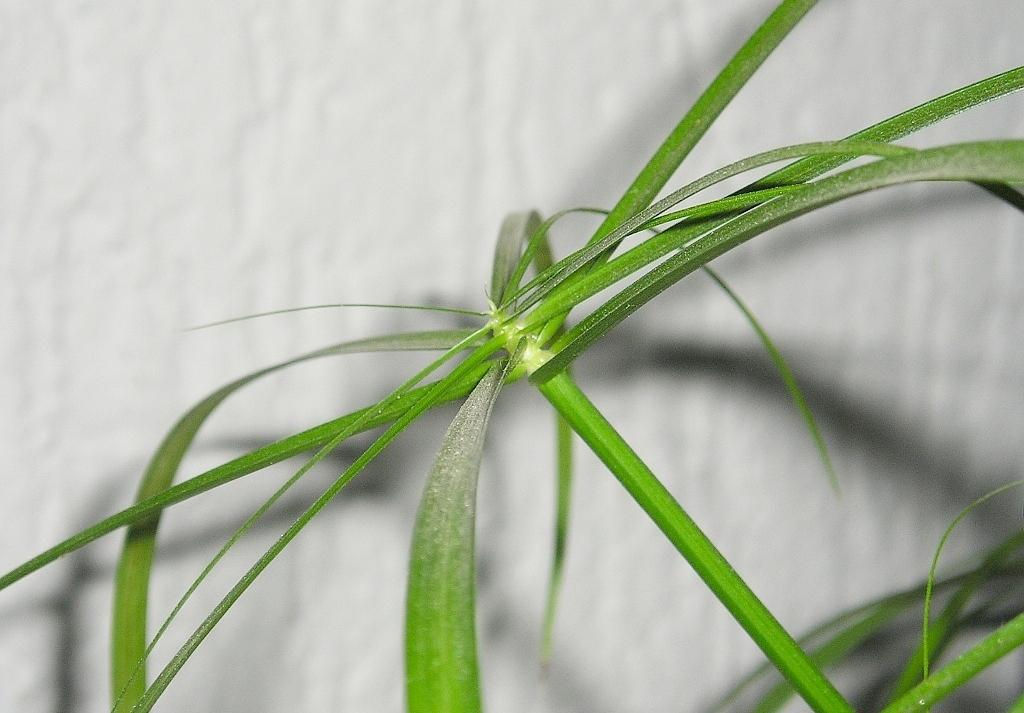What type of plant material is present in the image? There are leaves with a stem in the image. What color is the background of the image? The background of the image is white. How many times does the dad sneeze in the image? There is no dad or sneezing present in the image; it only features leaves with a stem against a white background. 